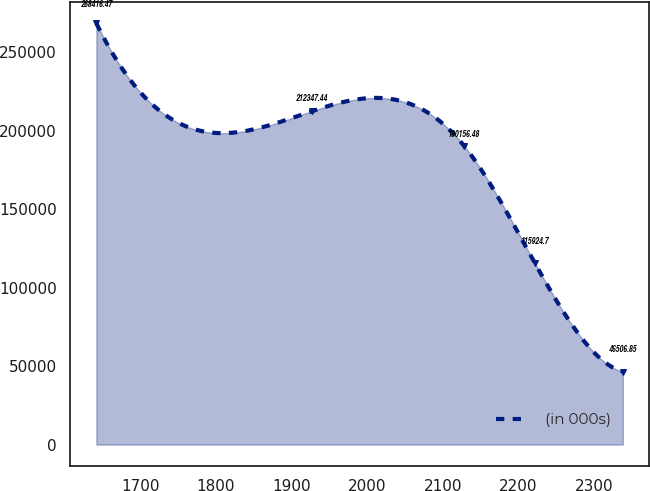Convert chart to OTSL. <chart><loc_0><loc_0><loc_500><loc_500><line_chart><ecel><fcel>(in 000s)<nl><fcel>1642.13<fcel>268416<nl><fcel>1926.73<fcel>212347<nl><fcel>2128.54<fcel>190156<nl><fcel>2221.57<fcel>115925<nl><fcel>2338.16<fcel>46506.8<nl></chart> 